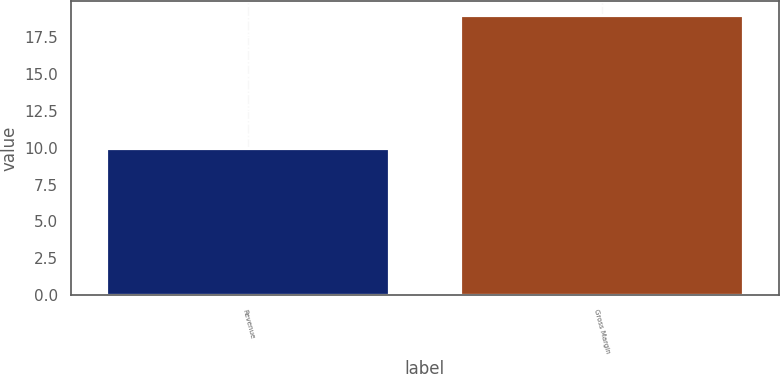Convert chart. <chart><loc_0><loc_0><loc_500><loc_500><bar_chart><fcel>Revenue<fcel>Gross Margin<nl><fcel>10<fcel>19<nl></chart> 